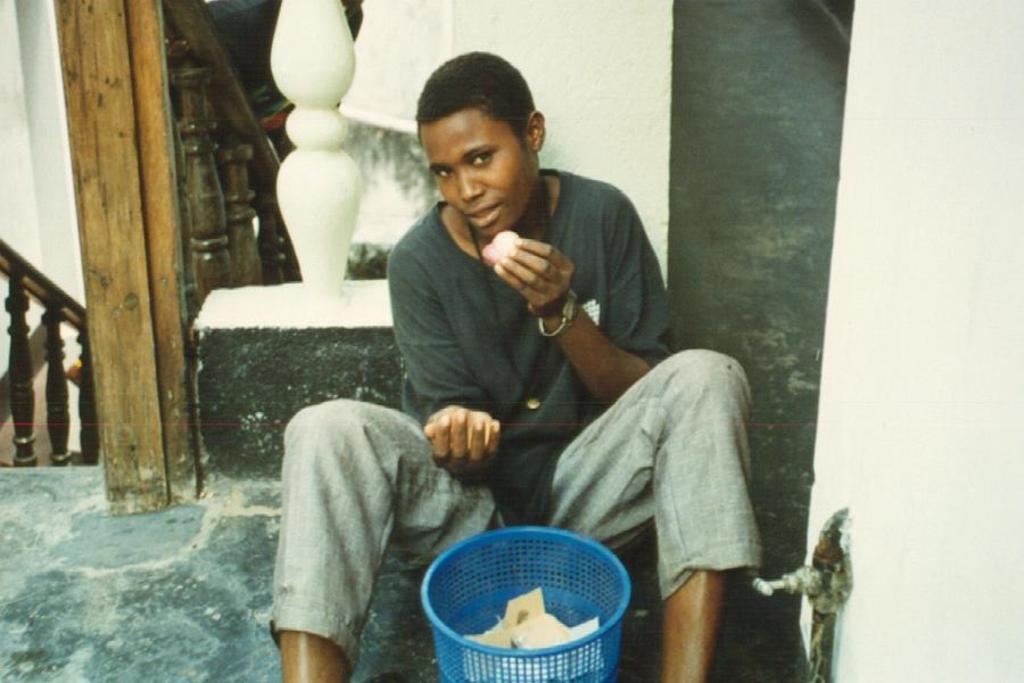In one or two sentences, can you explain what this image depicts? In this image there is a person sitting on the floor and holding an object, and there are papers in a dustbin, and in the background there is a staircase. 